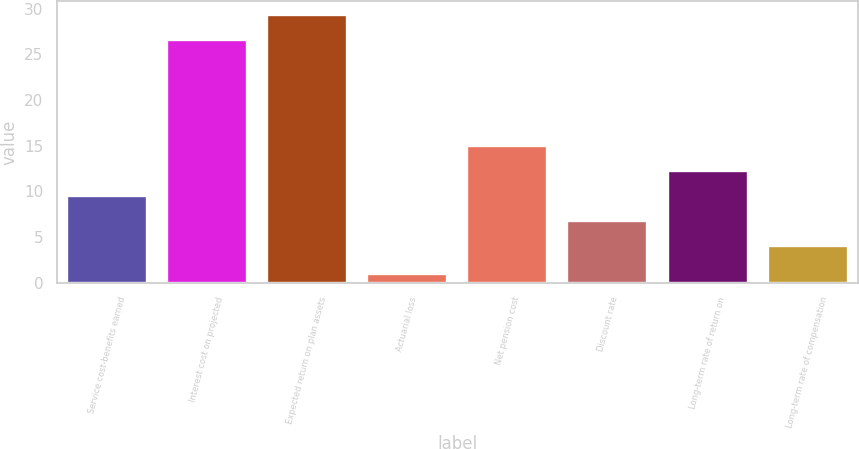<chart> <loc_0><loc_0><loc_500><loc_500><bar_chart><fcel>Service cost-benefits earned<fcel>Interest cost on projected<fcel>Expected return on plan assets<fcel>Actuarial loss<fcel>Net pension cost<fcel>Discount rate<fcel>Long-term rate of return on<fcel>Long-term rate of compensation<nl><fcel>9.5<fcel>26.6<fcel>29.34<fcel>0.9<fcel>14.98<fcel>6.76<fcel>12.24<fcel>4.02<nl></chart> 